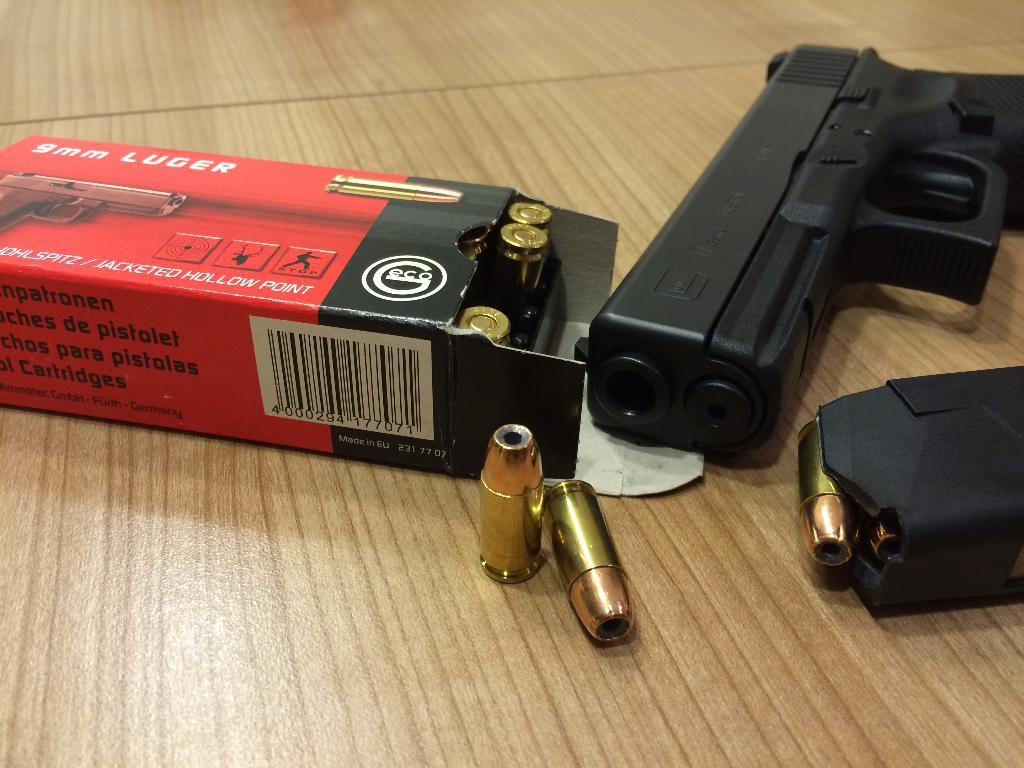Where was the image taken? The image is taken indoors. What furniture is present in the image? There is a table in the image. What objects are on the table? There is a gun and a box with bullets on the table. Can you see your sister playing with a yoke in the image? There is no sister or yoke present in the image. What type of animals can be seen at the zoo in the image? There is no zoo or animals present in the image. 